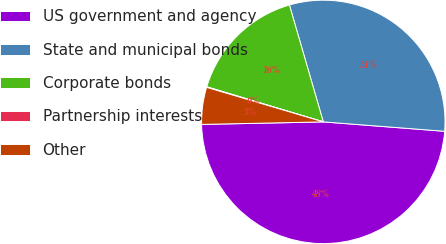Convert chart to OTSL. <chart><loc_0><loc_0><loc_500><loc_500><pie_chart><fcel>US government and agency<fcel>State and municipal bonds<fcel>Corporate bonds<fcel>Partnership interests<fcel>Other<nl><fcel>48.44%<fcel>30.72%<fcel>15.85%<fcel>0.08%<fcel>4.91%<nl></chart> 